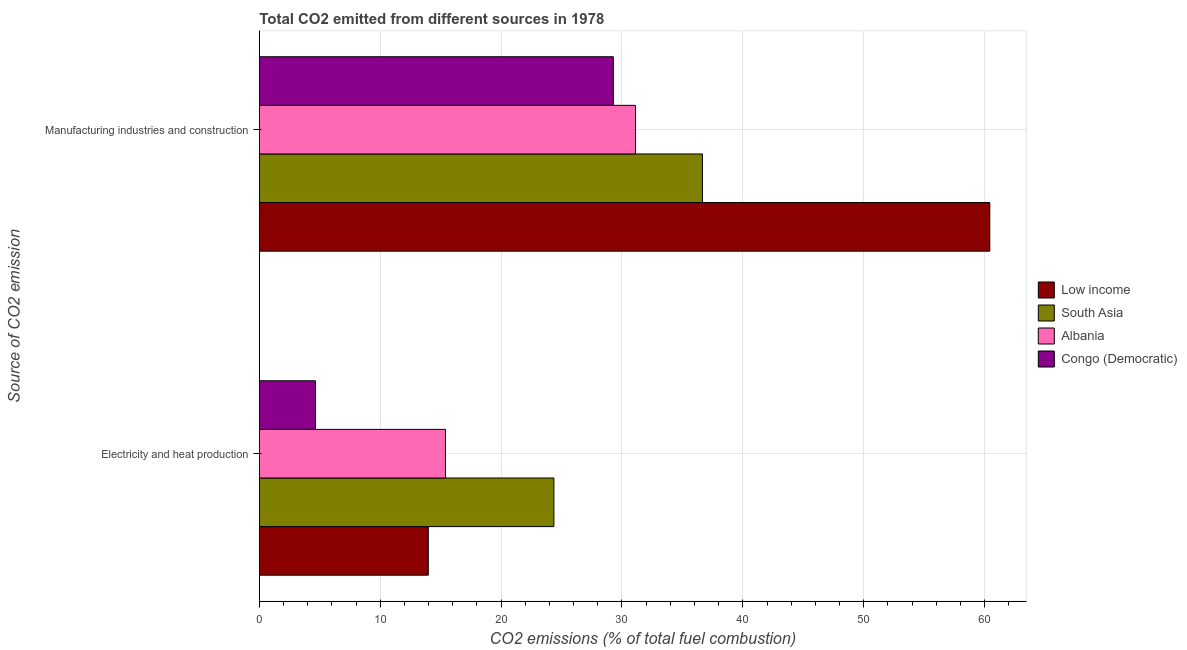What is the label of the 1st group of bars from the top?
Provide a short and direct response. Manufacturing industries and construction. What is the co2 emissions due to manufacturing industries in Congo (Democratic)?
Give a very brief answer. 29.29. Across all countries, what is the maximum co2 emissions due to electricity and heat production?
Offer a terse response. 24.37. Across all countries, what is the minimum co2 emissions due to electricity and heat production?
Your answer should be very brief. 4.64. In which country was the co2 emissions due to electricity and heat production maximum?
Your response must be concise. South Asia. In which country was the co2 emissions due to manufacturing industries minimum?
Provide a succinct answer. Congo (Democratic). What is the total co2 emissions due to manufacturing industries in the graph?
Your answer should be compact. 157.49. What is the difference between the co2 emissions due to manufacturing industries in Congo (Democratic) and that in Low income?
Your answer should be very brief. -31.14. What is the difference between the co2 emissions due to electricity and heat production in Low income and the co2 emissions due to manufacturing industries in Congo (Democratic)?
Offer a terse response. -15.31. What is the average co2 emissions due to manufacturing industries per country?
Offer a very short reply. 39.37. What is the difference between the co2 emissions due to electricity and heat production and co2 emissions due to manufacturing industries in Low income?
Your response must be concise. -46.45. What is the ratio of the co2 emissions due to manufacturing industries in Low income to that in Albania?
Your response must be concise. 1.94. Is the co2 emissions due to manufacturing industries in Low income less than that in South Asia?
Provide a succinct answer. No. In how many countries, is the co2 emissions due to electricity and heat production greater than the average co2 emissions due to electricity and heat production taken over all countries?
Make the answer very short. 2. What does the 3rd bar from the bottom in Manufacturing industries and construction represents?
Your response must be concise. Albania. How many bars are there?
Ensure brevity in your answer.  8. Are all the bars in the graph horizontal?
Ensure brevity in your answer.  Yes. How many countries are there in the graph?
Provide a succinct answer. 4. Does the graph contain grids?
Your answer should be compact. Yes. Where does the legend appear in the graph?
Give a very brief answer. Center right. How many legend labels are there?
Make the answer very short. 4. How are the legend labels stacked?
Ensure brevity in your answer.  Vertical. What is the title of the graph?
Your response must be concise. Total CO2 emitted from different sources in 1978. Does "Peru" appear as one of the legend labels in the graph?
Give a very brief answer. No. What is the label or title of the X-axis?
Provide a short and direct response. CO2 emissions (% of total fuel combustion). What is the label or title of the Y-axis?
Provide a short and direct response. Source of CO2 emission. What is the CO2 emissions (% of total fuel combustion) of Low income in Electricity and heat production?
Provide a short and direct response. 13.98. What is the CO2 emissions (% of total fuel combustion) of South Asia in Electricity and heat production?
Give a very brief answer. 24.37. What is the CO2 emissions (% of total fuel combustion) of Albania in Electricity and heat production?
Keep it short and to the point. 15.4. What is the CO2 emissions (% of total fuel combustion) of Congo (Democratic) in Electricity and heat production?
Provide a short and direct response. 4.64. What is the CO2 emissions (% of total fuel combustion) of Low income in Manufacturing industries and construction?
Provide a succinct answer. 60.43. What is the CO2 emissions (% of total fuel combustion) of South Asia in Manufacturing industries and construction?
Your answer should be compact. 36.66. What is the CO2 emissions (% of total fuel combustion) of Albania in Manufacturing industries and construction?
Your response must be concise. 31.12. What is the CO2 emissions (% of total fuel combustion) in Congo (Democratic) in Manufacturing industries and construction?
Your answer should be very brief. 29.29. Across all Source of CO2 emission, what is the maximum CO2 emissions (% of total fuel combustion) in Low income?
Ensure brevity in your answer.  60.43. Across all Source of CO2 emission, what is the maximum CO2 emissions (% of total fuel combustion) in South Asia?
Offer a very short reply. 36.66. Across all Source of CO2 emission, what is the maximum CO2 emissions (% of total fuel combustion) in Albania?
Offer a terse response. 31.12. Across all Source of CO2 emission, what is the maximum CO2 emissions (% of total fuel combustion) of Congo (Democratic)?
Your answer should be very brief. 29.29. Across all Source of CO2 emission, what is the minimum CO2 emissions (% of total fuel combustion) of Low income?
Provide a short and direct response. 13.98. Across all Source of CO2 emission, what is the minimum CO2 emissions (% of total fuel combustion) in South Asia?
Keep it short and to the point. 24.37. Across all Source of CO2 emission, what is the minimum CO2 emissions (% of total fuel combustion) in Albania?
Your answer should be compact. 15.4. Across all Source of CO2 emission, what is the minimum CO2 emissions (% of total fuel combustion) in Congo (Democratic)?
Offer a very short reply. 4.64. What is the total CO2 emissions (% of total fuel combustion) of Low income in the graph?
Offer a very short reply. 74.41. What is the total CO2 emissions (% of total fuel combustion) of South Asia in the graph?
Provide a short and direct response. 61.02. What is the total CO2 emissions (% of total fuel combustion) in Albania in the graph?
Provide a succinct answer. 46.52. What is the total CO2 emissions (% of total fuel combustion) of Congo (Democratic) in the graph?
Give a very brief answer. 33.93. What is the difference between the CO2 emissions (% of total fuel combustion) of Low income in Electricity and heat production and that in Manufacturing industries and construction?
Keep it short and to the point. -46.45. What is the difference between the CO2 emissions (% of total fuel combustion) of South Asia in Electricity and heat production and that in Manufacturing industries and construction?
Offer a very short reply. -12.29. What is the difference between the CO2 emissions (% of total fuel combustion) of Albania in Electricity and heat production and that in Manufacturing industries and construction?
Make the answer very short. -15.72. What is the difference between the CO2 emissions (% of total fuel combustion) of Congo (Democratic) in Electricity and heat production and that in Manufacturing industries and construction?
Offer a terse response. -24.64. What is the difference between the CO2 emissions (% of total fuel combustion) in Low income in Electricity and heat production and the CO2 emissions (% of total fuel combustion) in South Asia in Manufacturing industries and construction?
Offer a terse response. -22.68. What is the difference between the CO2 emissions (% of total fuel combustion) of Low income in Electricity and heat production and the CO2 emissions (% of total fuel combustion) of Albania in Manufacturing industries and construction?
Provide a short and direct response. -17.14. What is the difference between the CO2 emissions (% of total fuel combustion) in Low income in Electricity and heat production and the CO2 emissions (% of total fuel combustion) in Congo (Democratic) in Manufacturing industries and construction?
Give a very brief answer. -15.31. What is the difference between the CO2 emissions (% of total fuel combustion) of South Asia in Electricity and heat production and the CO2 emissions (% of total fuel combustion) of Albania in Manufacturing industries and construction?
Your response must be concise. -6.75. What is the difference between the CO2 emissions (% of total fuel combustion) in South Asia in Electricity and heat production and the CO2 emissions (% of total fuel combustion) in Congo (Democratic) in Manufacturing industries and construction?
Your response must be concise. -4.92. What is the difference between the CO2 emissions (% of total fuel combustion) of Albania in Electricity and heat production and the CO2 emissions (% of total fuel combustion) of Congo (Democratic) in Manufacturing industries and construction?
Provide a short and direct response. -13.89. What is the average CO2 emissions (% of total fuel combustion) of Low income per Source of CO2 emission?
Your answer should be compact. 37.2. What is the average CO2 emissions (% of total fuel combustion) in South Asia per Source of CO2 emission?
Your response must be concise. 30.51. What is the average CO2 emissions (% of total fuel combustion) in Albania per Source of CO2 emission?
Provide a short and direct response. 23.26. What is the average CO2 emissions (% of total fuel combustion) in Congo (Democratic) per Source of CO2 emission?
Keep it short and to the point. 16.96. What is the difference between the CO2 emissions (% of total fuel combustion) of Low income and CO2 emissions (% of total fuel combustion) of South Asia in Electricity and heat production?
Your answer should be compact. -10.39. What is the difference between the CO2 emissions (% of total fuel combustion) of Low income and CO2 emissions (% of total fuel combustion) of Albania in Electricity and heat production?
Give a very brief answer. -1.42. What is the difference between the CO2 emissions (% of total fuel combustion) of Low income and CO2 emissions (% of total fuel combustion) of Congo (Democratic) in Electricity and heat production?
Ensure brevity in your answer.  9.33. What is the difference between the CO2 emissions (% of total fuel combustion) in South Asia and CO2 emissions (% of total fuel combustion) in Albania in Electricity and heat production?
Provide a short and direct response. 8.97. What is the difference between the CO2 emissions (% of total fuel combustion) in South Asia and CO2 emissions (% of total fuel combustion) in Congo (Democratic) in Electricity and heat production?
Ensure brevity in your answer.  19.72. What is the difference between the CO2 emissions (% of total fuel combustion) in Albania and CO2 emissions (% of total fuel combustion) in Congo (Democratic) in Electricity and heat production?
Provide a succinct answer. 10.75. What is the difference between the CO2 emissions (% of total fuel combustion) in Low income and CO2 emissions (% of total fuel combustion) in South Asia in Manufacturing industries and construction?
Offer a terse response. 23.77. What is the difference between the CO2 emissions (% of total fuel combustion) of Low income and CO2 emissions (% of total fuel combustion) of Albania in Manufacturing industries and construction?
Your response must be concise. 29.31. What is the difference between the CO2 emissions (% of total fuel combustion) in Low income and CO2 emissions (% of total fuel combustion) in Congo (Democratic) in Manufacturing industries and construction?
Offer a terse response. 31.14. What is the difference between the CO2 emissions (% of total fuel combustion) in South Asia and CO2 emissions (% of total fuel combustion) in Albania in Manufacturing industries and construction?
Your response must be concise. 5.54. What is the difference between the CO2 emissions (% of total fuel combustion) in South Asia and CO2 emissions (% of total fuel combustion) in Congo (Democratic) in Manufacturing industries and construction?
Provide a succinct answer. 7.37. What is the difference between the CO2 emissions (% of total fuel combustion) in Albania and CO2 emissions (% of total fuel combustion) in Congo (Democratic) in Manufacturing industries and construction?
Offer a terse response. 1.83. What is the ratio of the CO2 emissions (% of total fuel combustion) in Low income in Electricity and heat production to that in Manufacturing industries and construction?
Offer a terse response. 0.23. What is the ratio of the CO2 emissions (% of total fuel combustion) in South Asia in Electricity and heat production to that in Manufacturing industries and construction?
Provide a succinct answer. 0.66. What is the ratio of the CO2 emissions (% of total fuel combustion) in Albania in Electricity and heat production to that in Manufacturing industries and construction?
Provide a short and direct response. 0.49. What is the ratio of the CO2 emissions (% of total fuel combustion) of Congo (Democratic) in Electricity and heat production to that in Manufacturing industries and construction?
Provide a short and direct response. 0.16. What is the difference between the highest and the second highest CO2 emissions (% of total fuel combustion) in Low income?
Your answer should be very brief. 46.45. What is the difference between the highest and the second highest CO2 emissions (% of total fuel combustion) of South Asia?
Offer a terse response. 12.29. What is the difference between the highest and the second highest CO2 emissions (% of total fuel combustion) in Albania?
Offer a terse response. 15.72. What is the difference between the highest and the second highest CO2 emissions (% of total fuel combustion) in Congo (Democratic)?
Offer a very short reply. 24.64. What is the difference between the highest and the lowest CO2 emissions (% of total fuel combustion) of Low income?
Provide a succinct answer. 46.45. What is the difference between the highest and the lowest CO2 emissions (% of total fuel combustion) of South Asia?
Give a very brief answer. 12.29. What is the difference between the highest and the lowest CO2 emissions (% of total fuel combustion) of Albania?
Offer a terse response. 15.72. What is the difference between the highest and the lowest CO2 emissions (% of total fuel combustion) of Congo (Democratic)?
Give a very brief answer. 24.64. 